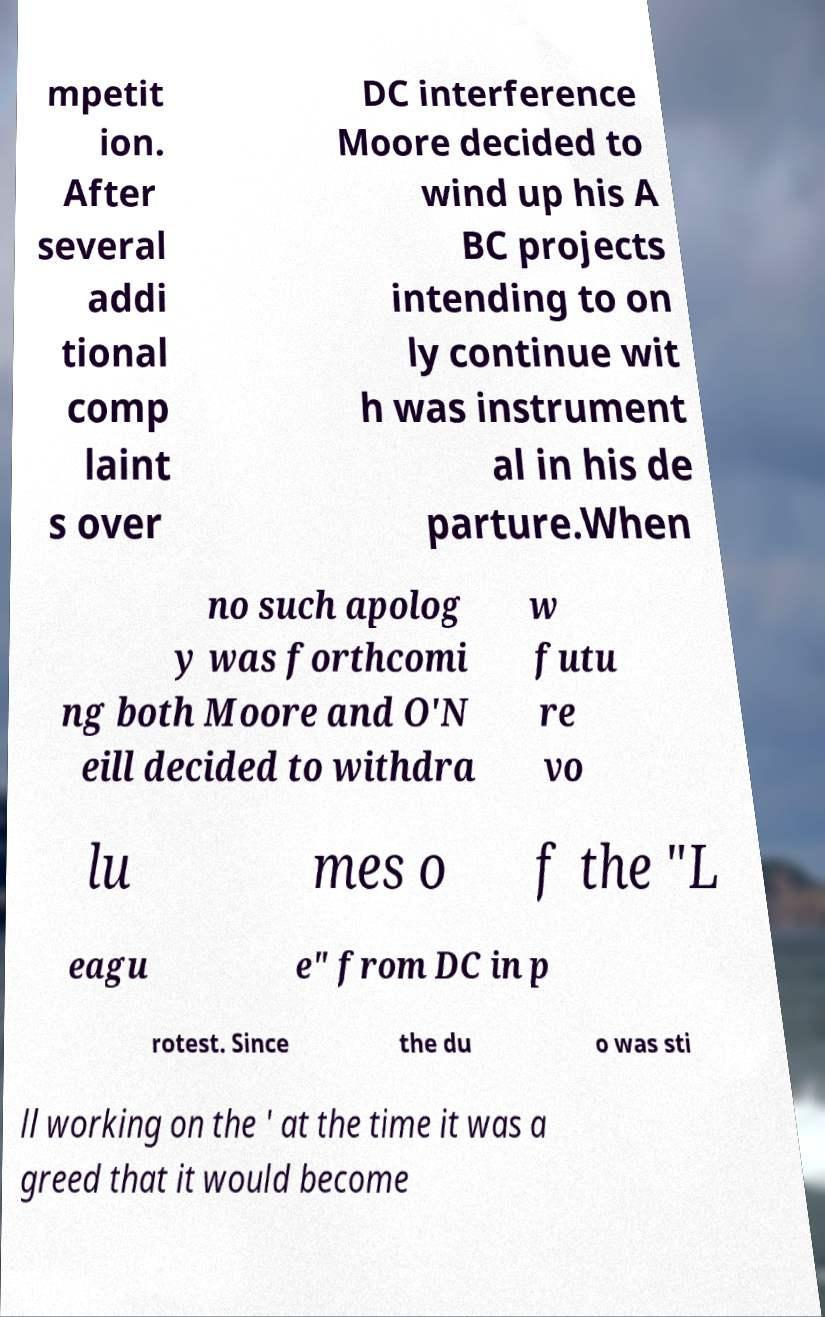I need the written content from this picture converted into text. Can you do that? mpetit ion. After several addi tional comp laint s over DC interference Moore decided to wind up his A BC projects intending to on ly continue wit h was instrument al in his de parture.When no such apolog y was forthcomi ng both Moore and O'N eill decided to withdra w futu re vo lu mes o f the "L eagu e" from DC in p rotest. Since the du o was sti ll working on the ' at the time it was a greed that it would become 